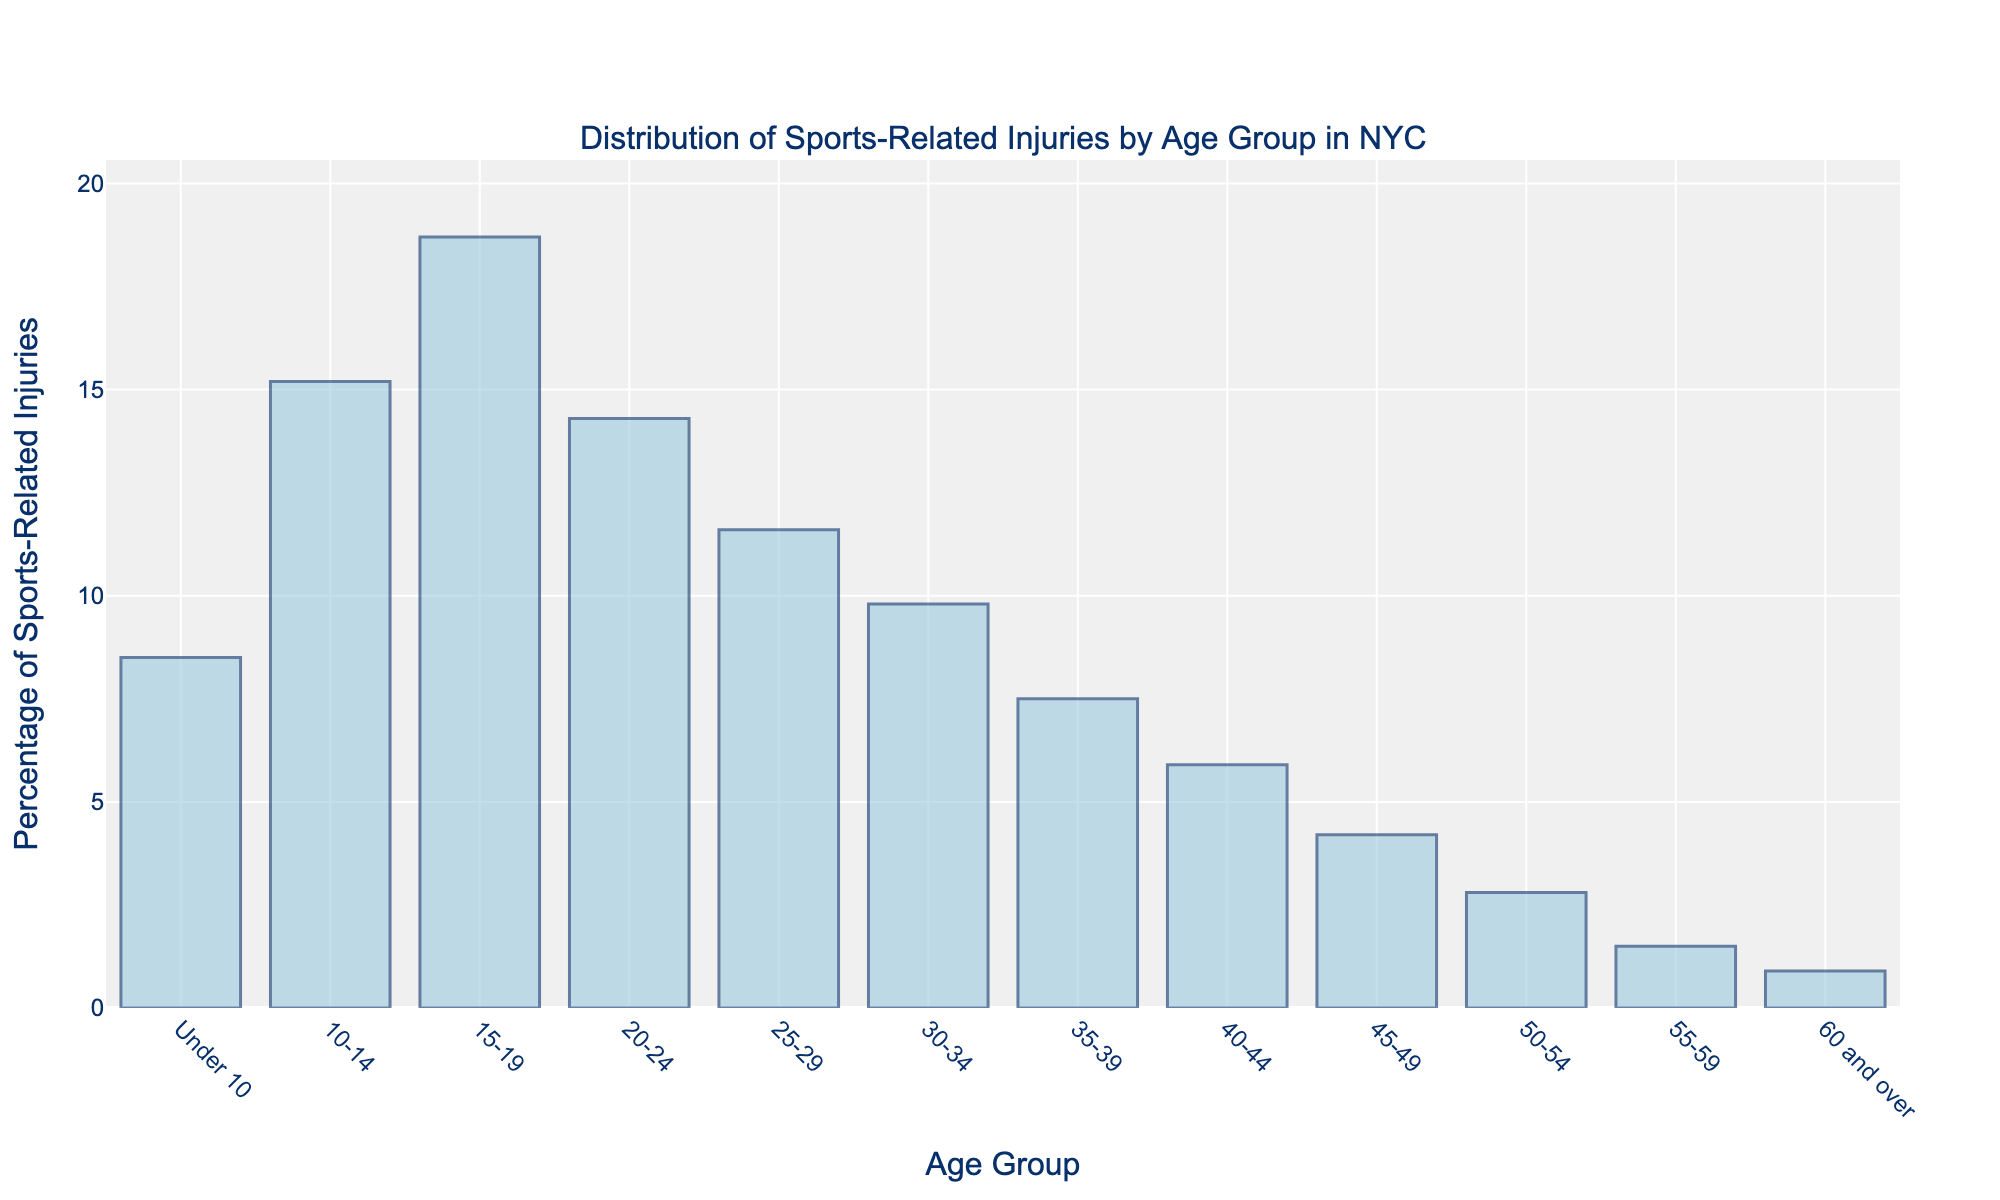What's the highest percentage of sports-related injuries for any age group? Identify the tallest bar in the chart. The bar representing the age group 15-19 has the highest percentage.
Answer: 18.7% Which age group has the lowest percentage of sports-related injuries? Identify the shortest bar in the chart. The bar representing the age group 60 and over has the lowest percentage.
Answer: 0.9% How many age groups have a percentage of sports-related injuries above 10%? Count the bars with percentages above the 10% line. The age groups that have percentages above 10% are: 10-14, 15-19, 20-24, 25-29.
Answer: 4 What’s the difference in percentage of sports-related injuries between the age groups 10-14 and 50-54? Find the percentage values for both age groups and subtract the percentage for the age group 50-54 from the percentage for the age group 10-14: 15.2% - 2.8% = 12.4%.
Answer: 12.4% What is the average percentage of sports-related injuries for the age groups 25-29, 30-34, and 35-39? Average is calculated by summing the percentages for the age groups and dividing by the number of age groups: (11.6% + 9.8% + 7.5%) / 3 = 9.63%.
Answer: 9.63% Are there more sports-related injuries in the age group 20-24 or 40-44? Compare the heights of the bars for the age groups 20-24 and 40-44. The bar representing 20-24 is taller than that for 40-44, indicating more injuries.
Answer: 20-24 What's the sum of percentages for the age groups 15-19 and 25-29? Add the percentages for the age groups: 18.7% + 11.6% = 30.3%.
Answer: 30.3% Does the percentage of sports-related injuries for the age group 30-34 exceed 10%? Compare the height of the bar for the age group 30-34 with the 10% line. The bar is below 10%, indicating it does not exceed 10%.
Answer: No 